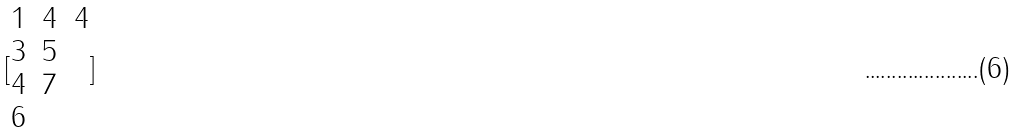Convert formula to latex. <formula><loc_0><loc_0><loc_500><loc_500>[ \begin{matrix} 1 & 4 & 4 \\ 3 & 5 \\ 4 & 7 \\ 6 \end{matrix} ]</formula> 